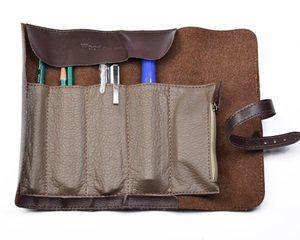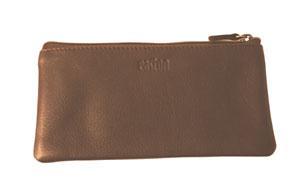The first image is the image on the left, the second image is the image on the right. Considering the images on both sides, is "The left image shows one filled brown leather pencil case opened and right-side up, and the right image contains no more than two pencil cases." valid? Answer yes or no. Yes. The first image is the image on the left, the second image is the image on the right. Examine the images to the left and right. Is the description "there is a brown Swede pencil pouch open and displaying 5 pockets , the pockets have pens and pencils and there is a leather strap attached" accurate? Answer yes or no. Yes. 